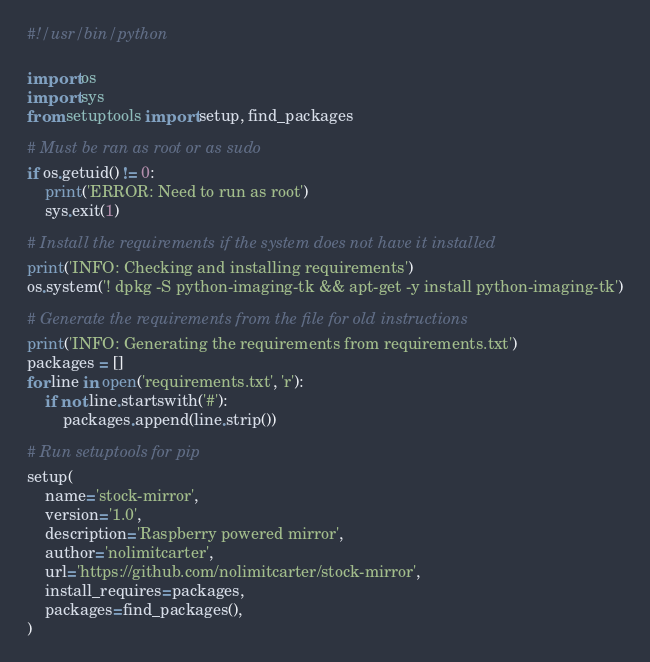<code> <loc_0><loc_0><loc_500><loc_500><_Python_>#!/usr/bin/python

import os
import sys
from setuptools import setup, find_packages

# Must be ran as root or as sudo
if os.getuid() != 0:
    print('ERROR: Need to run as root')
    sys.exit(1)

# Install the requirements if the system does not have it installed
print('INFO: Checking and installing requirements')
os.system('! dpkg -S python-imaging-tk && apt-get -y install python-imaging-tk')

# Generate the requirements from the file for old instructions
print('INFO: Generating the requirements from requirements.txt')
packages = []
for line in open('requirements.txt', 'r'):
    if not line.startswith('#'):
        packages.append(line.strip())

# Run setuptools for pip
setup(
    name='stock-mirror',
    version='1.0',
    description='Raspberry powered mirror',
    author='nolimitcarter',
    url='https://github.com/nolimitcarter/stock-mirror',
    install_requires=packages,
    packages=find_packages(),
)
</code> 